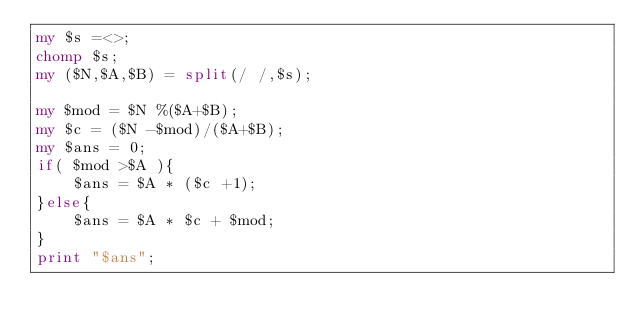<code> <loc_0><loc_0><loc_500><loc_500><_Perl_>my $s =<>;
chomp $s;
my ($N,$A,$B) = split(/ /,$s);

my $mod = $N %($A+$B);
my $c = ($N -$mod)/($A+$B);
my $ans = 0;
if( $mod >$A ){
    $ans = $A * ($c +1);
}else{
    $ans = $A * $c + $mod;
}
print "$ans";</code> 